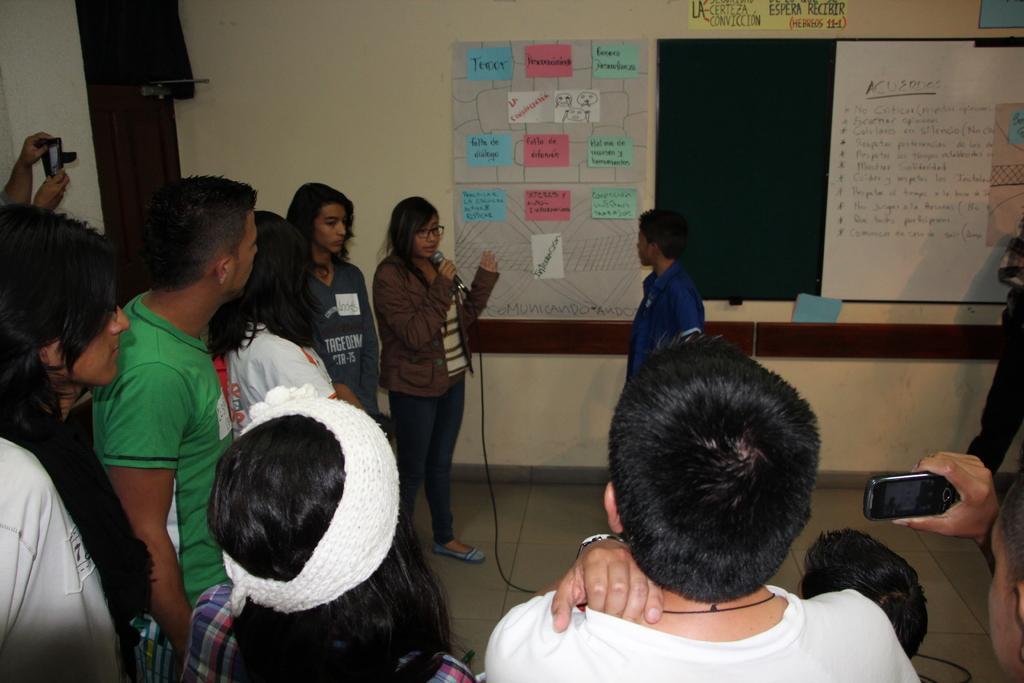Describe this image in one or two sentences. In this image we can see a group of people standing on the floor. In that a man is holding a cellphone and a woman is holding a mic with a wire. On the backside we can see a board on a wall with some papers pasted on it and a door. 